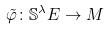<formula> <loc_0><loc_0><loc_500><loc_500>\tilde { \varphi } \colon \mathbb { S } ^ { \lambda } E \rightarrow M</formula> 